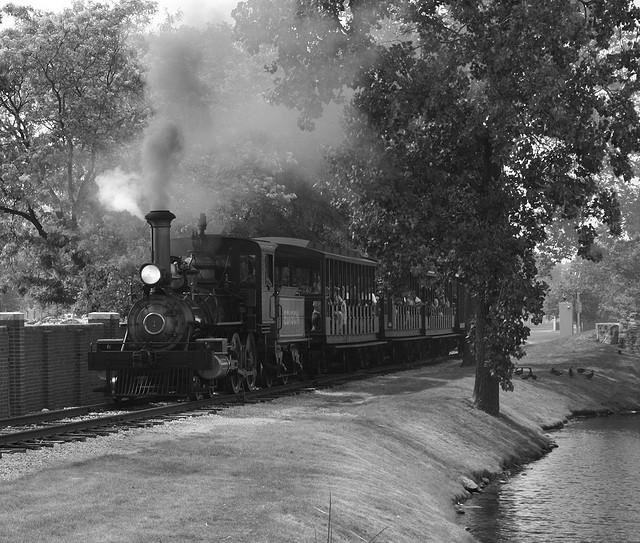What is the state of the colors here? Please explain your reasoning. black/white. The other options don't apply to this type of photograph. 